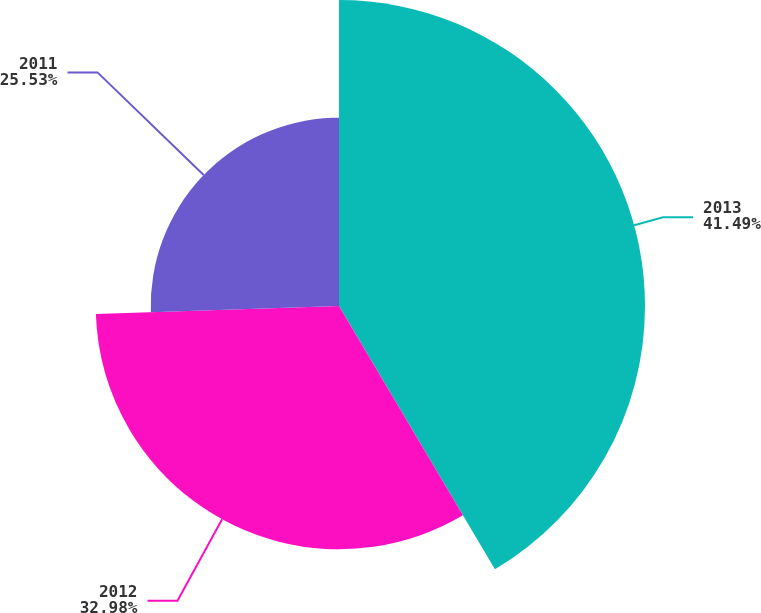Convert chart. <chart><loc_0><loc_0><loc_500><loc_500><pie_chart><fcel>2013<fcel>2012<fcel>2011<nl><fcel>41.49%<fcel>32.98%<fcel>25.53%<nl></chart> 